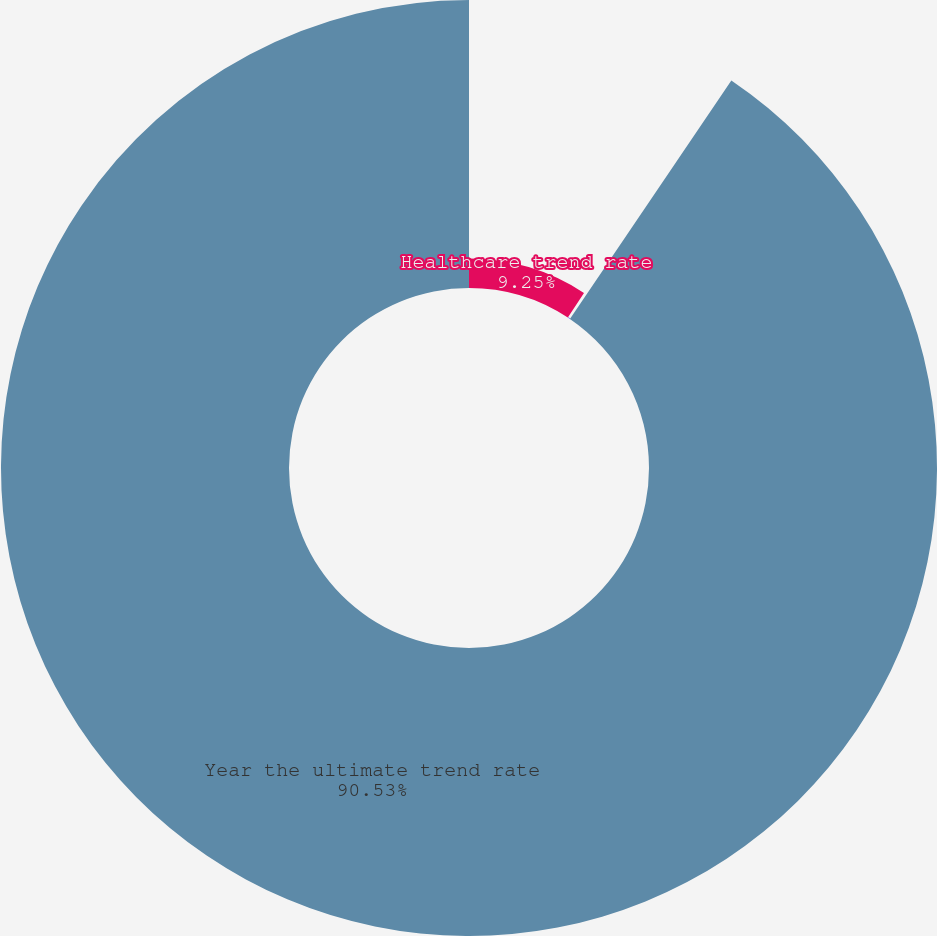Convert chart. <chart><loc_0><loc_0><loc_500><loc_500><pie_chart><fcel>Healthcare trend rate<fcel>Ultimate trend rate<fcel>Year the ultimate trend rate<nl><fcel>9.25%<fcel>0.22%<fcel>90.52%<nl></chart> 